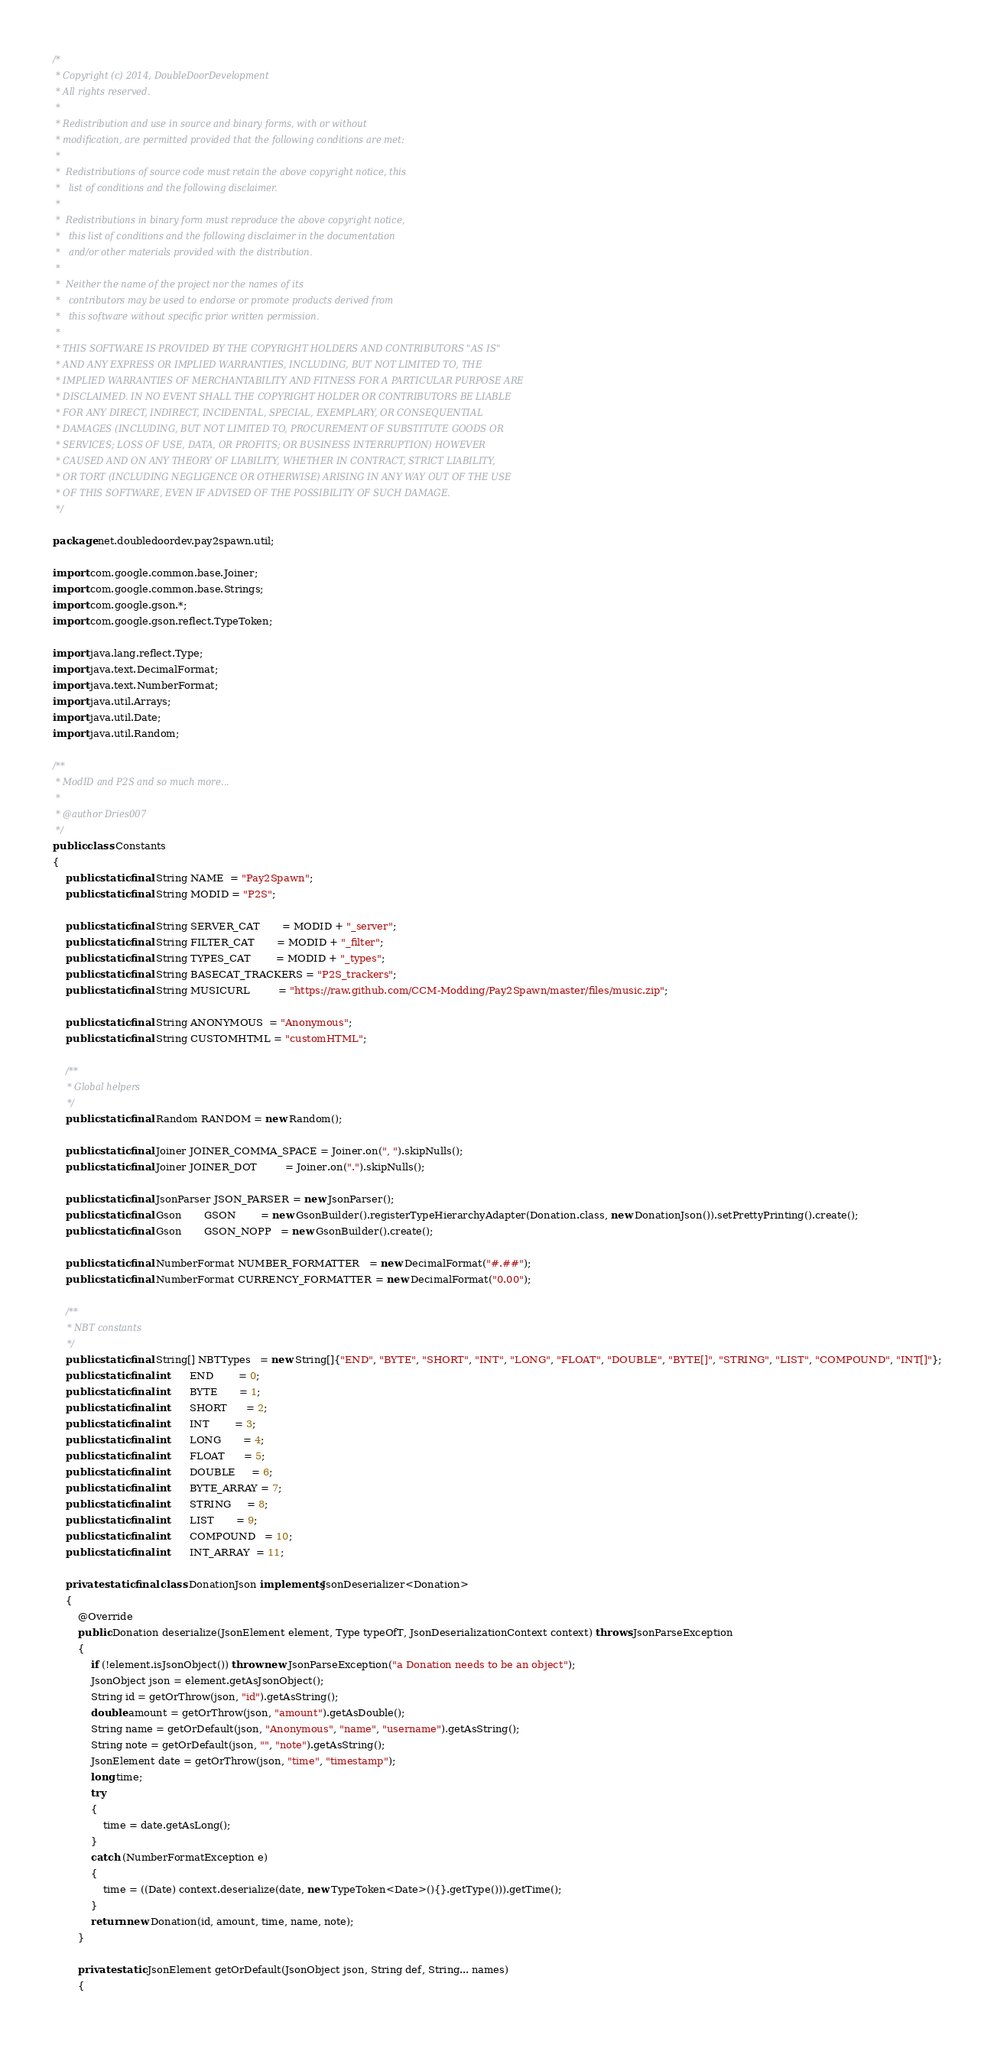Convert code to text. <code><loc_0><loc_0><loc_500><loc_500><_Java_>/*
 * Copyright (c) 2014, DoubleDoorDevelopment
 * All rights reserved.
 *
 * Redistribution and use in source and binary forms, with or without
 * modification, are permitted provided that the following conditions are met:
 *
 *  Redistributions of source code must retain the above copyright notice, this
 *   list of conditions and the following disclaimer.
 *
 *  Redistributions in binary form must reproduce the above copyright notice,
 *   this list of conditions and the following disclaimer in the documentation
 *   and/or other materials provided with the distribution.
 *
 *  Neither the name of the project nor the names of its
 *   contributors may be used to endorse or promote products derived from
 *   this software without specific prior written permission.
 *
 * THIS SOFTWARE IS PROVIDED BY THE COPYRIGHT HOLDERS AND CONTRIBUTORS "AS IS"
 * AND ANY EXPRESS OR IMPLIED WARRANTIES, INCLUDING, BUT NOT LIMITED TO, THE
 * IMPLIED WARRANTIES OF MERCHANTABILITY AND FITNESS FOR A PARTICULAR PURPOSE ARE
 * DISCLAIMED. IN NO EVENT SHALL THE COPYRIGHT HOLDER OR CONTRIBUTORS BE LIABLE
 * FOR ANY DIRECT, INDIRECT, INCIDENTAL, SPECIAL, EXEMPLARY, OR CONSEQUENTIAL
 * DAMAGES (INCLUDING, BUT NOT LIMITED TO, PROCUREMENT OF SUBSTITUTE GOODS OR
 * SERVICES; LOSS OF USE, DATA, OR PROFITS; OR BUSINESS INTERRUPTION) HOWEVER
 * CAUSED AND ON ANY THEORY OF LIABILITY, WHETHER IN CONTRACT, STRICT LIABILITY,
 * OR TORT (INCLUDING NEGLIGENCE OR OTHERWISE) ARISING IN ANY WAY OUT OF THE USE
 * OF THIS SOFTWARE, EVEN IF ADVISED OF THE POSSIBILITY OF SUCH DAMAGE.
 */

package net.doubledoordev.pay2spawn.util;

import com.google.common.base.Joiner;
import com.google.common.base.Strings;
import com.google.gson.*;
import com.google.gson.reflect.TypeToken;

import java.lang.reflect.Type;
import java.text.DecimalFormat;
import java.text.NumberFormat;
import java.util.Arrays;
import java.util.Date;
import java.util.Random;

/**
 * ModID and P2S and so much more...
 *
 * @author Dries007
 */
public class Constants
{
    public static final String NAME  = "Pay2Spawn";
    public static final String MODID = "P2S";

    public static final String SERVER_CAT       = MODID + "_server";
    public static final String FILTER_CAT       = MODID + "_filter";
    public static final String TYPES_CAT        = MODID + "_types";
    public static final String BASECAT_TRACKERS = "P2S_trackers";
    public static final String MUSICURL         = "https://raw.github.com/CCM-Modding/Pay2Spawn/master/files/music.zip";

    public static final String ANONYMOUS  = "Anonymous";
    public static final String CUSTOMHTML = "customHTML";

    /**
     * Global helpers
     */
    public static final Random RANDOM = new Random();

    public static final Joiner JOINER_COMMA_SPACE = Joiner.on(", ").skipNulls();
    public static final Joiner JOINER_DOT         = Joiner.on(".").skipNulls();

    public static final JsonParser JSON_PARSER = new JsonParser();
    public static final Gson       GSON        = new GsonBuilder().registerTypeHierarchyAdapter(Donation.class, new DonationJson()).setPrettyPrinting().create();
    public static final Gson       GSON_NOPP   = new GsonBuilder().create();

    public static final NumberFormat NUMBER_FORMATTER   = new DecimalFormat("#.##");
    public static final NumberFormat CURRENCY_FORMATTER = new DecimalFormat("0.00");

    /**
     * NBT constants
     */
    public static final String[] NBTTypes   = new String[]{"END", "BYTE", "SHORT", "INT", "LONG", "FLOAT", "DOUBLE", "BYTE[]", "STRING", "LIST", "COMPOUND", "INT[]"};
    public static final int      END        = 0;
    public static final int      BYTE       = 1;
    public static final int      SHORT      = 2;
    public static final int      INT        = 3;
    public static final int      LONG       = 4;
    public static final int      FLOAT      = 5;
    public static final int      DOUBLE     = 6;
    public static final int      BYTE_ARRAY = 7;
    public static final int      STRING     = 8;
    public static final int      LIST       = 9;
    public static final int      COMPOUND   = 10;
    public static final int      INT_ARRAY  = 11;

    private static final class DonationJson implements JsonDeserializer<Donation>
    {
        @Override
        public Donation deserialize(JsonElement element, Type typeOfT, JsonDeserializationContext context) throws JsonParseException
        {
            if (!element.isJsonObject()) throw new JsonParseException("a Donation needs to be an object");
            JsonObject json = element.getAsJsonObject();
            String id = getOrThrow(json, "id").getAsString();
            double amount = getOrThrow(json, "amount").getAsDouble();
            String name = getOrDefault(json, "Anonymous", "name", "username").getAsString();
            String note = getOrDefault(json, "", "note").getAsString();
            JsonElement date = getOrThrow(json, "time", "timestamp");
            long time;
            try
            {
                time = date.getAsLong();
            }
            catch (NumberFormatException e)
            {
                time = ((Date) context.deserialize(date, new TypeToken<Date>(){}.getType())).getTime();
            }
            return new Donation(id, amount, time, name, note);
        }

        private static JsonElement getOrDefault(JsonObject json, String def, String... names)
        {</code> 